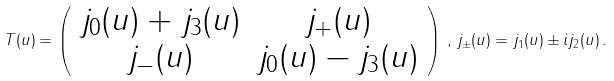<formula> <loc_0><loc_0><loc_500><loc_500>T ( u ) = \left ( \begin{array} { c c } j _ { 0 } ( u ) + j _ { 3 } ( u ) & j _ { + } ( u ) \\ j _ { - } ( u ) & j _ { 0 } ( u ) - j _ { 3 } ( u ) \\ \end{array} \right ) \, , \, j _ { \pm } ( u ) = j _ { 1 } ( u ) \pm i j _ { 2 } ( u ) \, .</formula> 